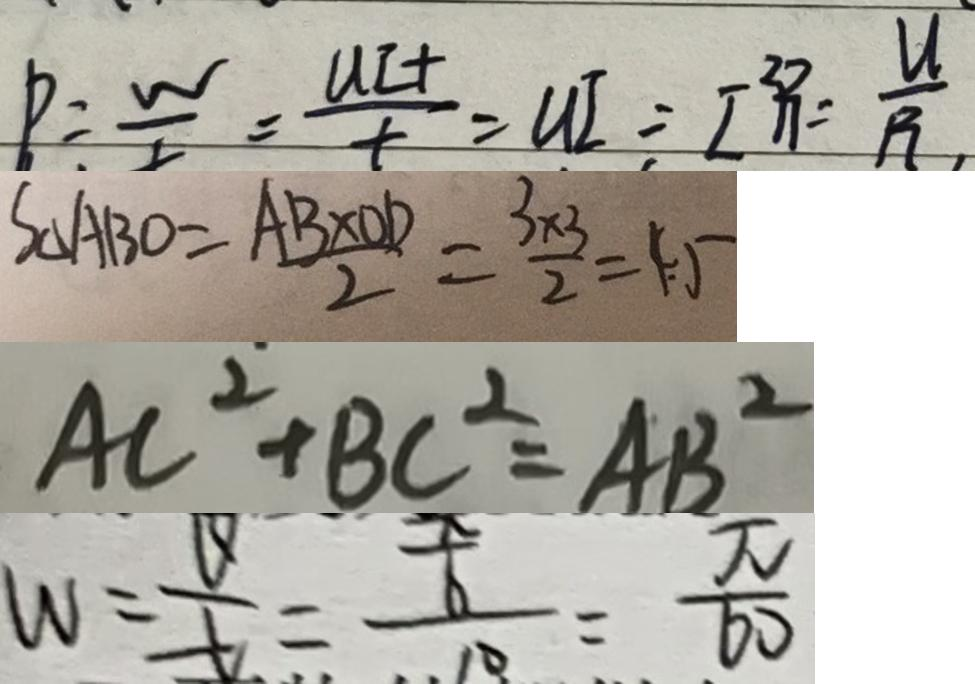Convert formula to latex. <formula><loc_0><loc_0><loc_500><loc_500>P = \frac { w } { t } = \frac { U I t } { t } = U I = I ^ { 2 } R = \frac { U } { R } , 
 S _ { \Delta A B O } = \frac { A B \times O D } { 2 } = \frac { 3 \times 3 } { 2 } = 4 . 5 
 A C ^ { 2 } + B C ^ { 2 } = A B ^ { 2 } 
 w = \frac { v } { t } = \frac { \frac { x } { 6 } } { 1 0 } = \frac { \pi } { 6 0 }</formula> 